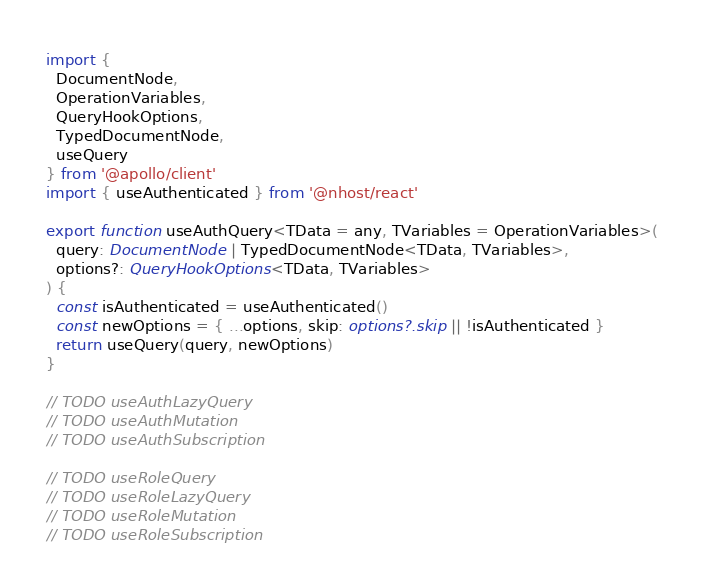Convert code to text. <code><loc_0><loc_0><loc_500><loc_500><_TypeScript_>import {
  DocumentNode,
  OperationVariables,
  QueryHookOptions,
  TypedDocumentNode,
  useQuery
} from '@apollo/client'
import { useAuthenticated } from '@nhost/react'

export function useAuthQuery<TData = any, TVariables = OperationVariables>(
  query: DocumentNode | TypedDocumentNode<TData, TVariables>,
  options?: QueryHookOptions<TData, TVariables>
) {
  const isAuthenticated = useAuthenticated()
  const newOptions = { ...options, skip: options?.skip || !isAuthenticated }
  return useQuery(query, newOptions)
}

// TODO useAuthLazyQuery
// TODO useAuthMutation
// TODO useAuthSubscription

// TODO useRoleQuery
// TODO useRoleLazyQuery
// TODO useRoleMutation
// TODO useRoleSubscription
</code> 